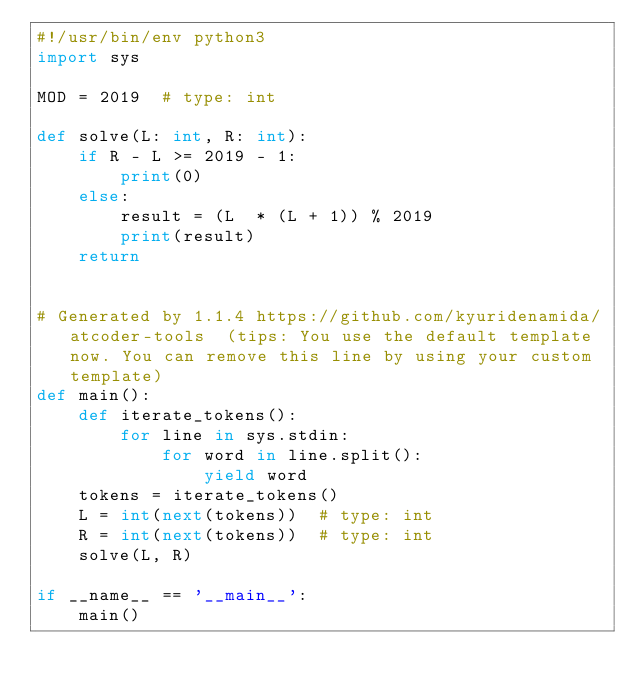<code> <loc_0><loc_0><loc_500><loc_500><_Python_>#!/usr/bin/env python3
import sys

MOD = 2019  # type: int

def solve(L: int, R: int):
    if R - L >= 2019 - 1:
        print(0)
    else:
        result = (L  * (L + 1)) % 2019
        print(result)
    return


# Generated by 1.1.4 https://github.com/kyuridenamida/atcoder-tools  (tips: You use the default template now. You can remove this line by using your custom template)
def main():
    def iterate_tokens():
        for line in sys.stdin:
            for word in line.split():
                yield word
    tokens = iterate_tokens()
    L = int(next(tokens))  # type: int
    R = int(next(tokens))  # type: int
    solve(L, R)

if __name__ == '__main__':
    main()
</code> 